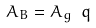Convert formula to latex. <formula><loc_0><loc_0><loc_500><loc_500>A _ { B } = A _ { g } \ q</formula> 